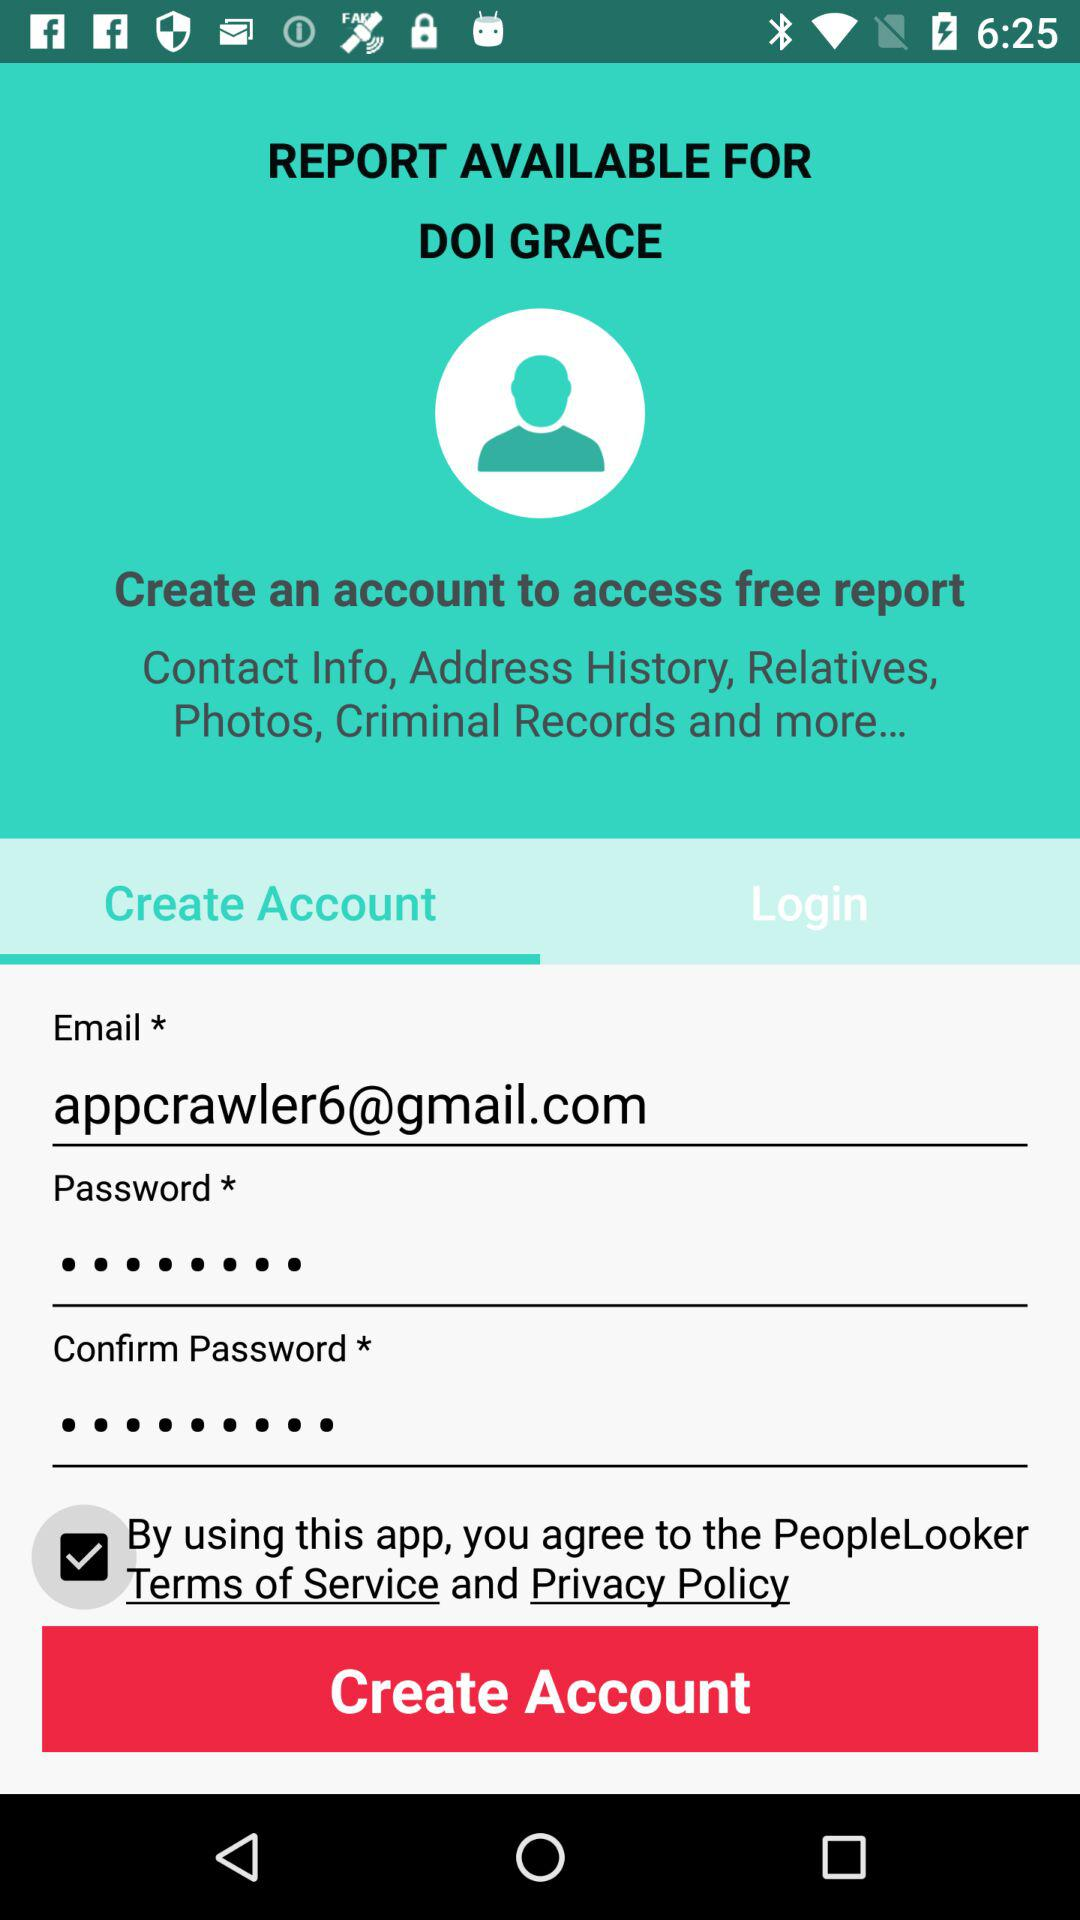What is the status of "By using this app, you agree to the PeopleLooker Terms of Service and Privacy Policy"? The status is "on". 